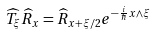Convert formula to latex. <formula><loc_0><loc_0><loc_500><loc_500>\widehat { T } _ { \xi } \widehat { R } _ { x } = \widehat { R } _ { x + \xi / 2 } e ^ { - \frac { i } { \hbar } { x } \wedge \xi } \</formula> 